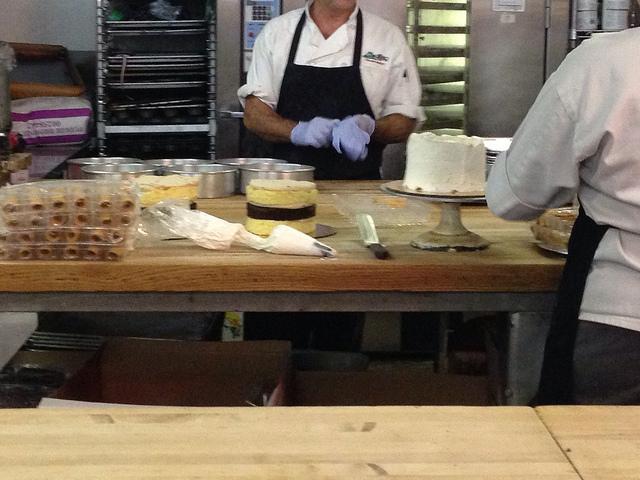How many people are cutting some cake?
Give a very brief answer. 1. How many cakes are there?
Give a very brief answer. 2. How many people can be seen?
Give a very brief answer. 2. How many buses are there?
Give a very brief answer. 0. 